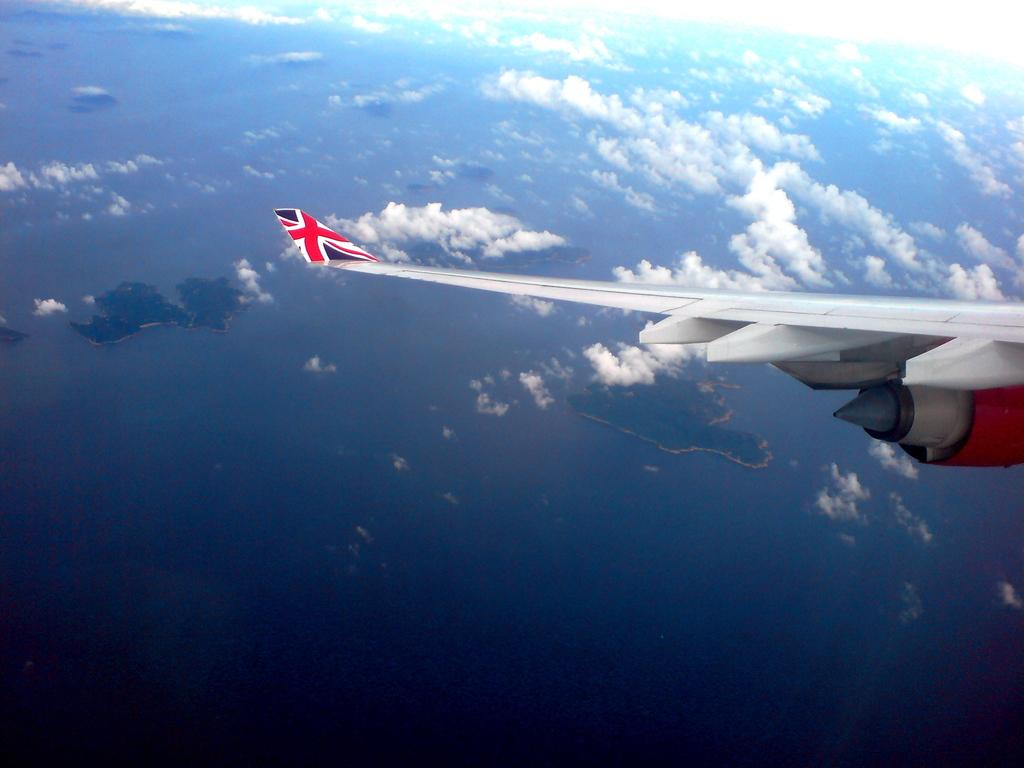What can be seen in the background of the image? There is sky in the image. What is present in the sky? There are clouds in the sky. What else is visible in the image? There is a wing of an airplane in the image. What type of anger can be seen on the wing of the airplane in the image? There is no anger present in the image, as it features a wing of an airplane and clouds in the sky. 